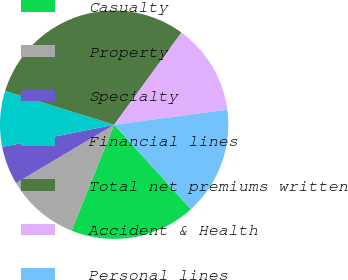<chart> <loc_0><loc_0><loc_500><loc_500><pie_chart><fcel>Casualty<fcel>Property<fcel>Specialty<fcel>Financial lines<fcel>Total net premiums written<fcel>Accident & Health<fcel>Personal lines<nl><fcel>17.83%<fcel>10.38%<fcel>5.41%<fcel>7.9%<fcel>30.25%<fcel>12.87%<fcel>15.35%<nl></chart> 